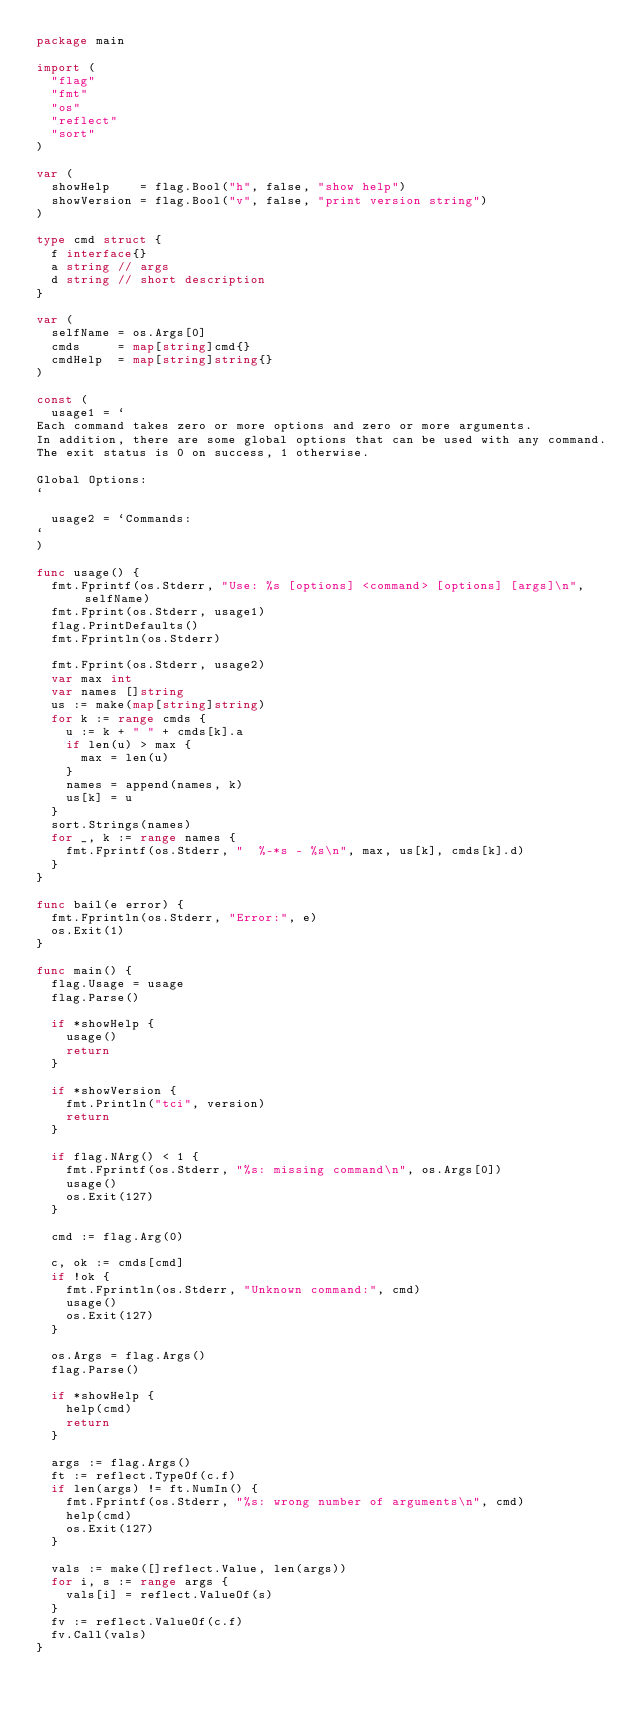<code> <loc_0><loc_0><loc_500><loc_500><_Go_>package main

import (
	"flag"
	"fmt"
	"os"
	"reflect"
	"sort"
)

var (
	showHelp    = flag.Bool("h", false, "show help")
	showVersion = flag.Bool("v", false, "print version string")
)

type cmd struct {
	f interface{}
	a string // args
	d string // short description
}

var (
	selfName = os.Args[0]
	cmds     = map[string]cmd{}
	cmdHelp  = map[string]string{}
)

const (
	usage1 = `
Each command takes zero or more options and zero or more arguments.
In addition, there are some global options that can be used with any command.
The exit status is 0 on success, 1 otherwise.

Global Options:
`

	usage2 = `Commands:
`
)

func usage() {
	fmt.Fprintf(os.Stderr, "Use: %s [options] <command> [options] [args]\n", selfName)
	fmt.Fprint(os.Stderr, usage1)
	flag.PrintDefaults()
	fmt.Fprintln(os.Stderr)

	fmt.Fprint(os.Stderr, usage2)
	var max int
	var names []string
	us := make(map[string]string)
	for k := range cmds {
		u := k + " " + cmds[k].a
		if len(u) > max {
			max = len(u)
		}
		names = append(names, k)
		us[k] = u
	}
	sort.Strings(names)
	for _, k := range names {
		fmt.Fprintf(os.Stderr, "  %-*s - %s\n", max, us[k], cmds[k].d)
	}
}

func bail(e error) {
	fmt.Fprintln(os.Stderr, "Error:", e)
	os.Exit(1)
}

func main() {
	flag.Usage = usage
	flag.Parse()

	if *showHelp {
		usage()
		return
	}

	if *showVersion {
		fmt.Println("tci", version)
		return
	}

	if flag.NArg() < 1 {
		fmt.Fprintf(os.Stderr, "%s: missing command\n", os.Args[0])
		usage()
		os.Exit(127)
	}

	cmd := flag.Arg(0)

	c, ok := cmds[cmd]
	if !ok {
		fmt.Fprintln(os.Stderr, "Unknown command:", cmd)
		usage()
		os.Exit(127)
	}

	os.Args = flag.Args()
	flag.Parse()

	if *showHelp {
		help(cmd)
		return
	}

	args := flag.Args()
	ft := reflect.TypeOf(c.f)
	if len(args) != ft.NumIn() {
		fmt.Fprintf(os.Stderr, "%s: wrong number of arguments\n", cmd)
		help(cmd)
		os.Exit(127)
	}

	vals := make([]reflect.Value, len(args))
	for i, s := range args {
		vals[i] = reflect.ValueOf(s)
	}
	fv := reflect.ValueOf(c.f)
	fv.Call(vals)
}
</code> 